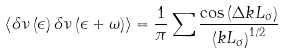Convert formula to latex. <formula><loc_0><loc_0><loc_500><loc_500>\left \langle \delta \nu \left ( \epsilon \right ) \delta \nu \left ( \epsilon + \omega \right ) \right \rangle = \frac { 1 } { \pi } \sum \frac { \cos \left ( \Delta k L _ { \sigma } \right ) } { \left ( k L _ { \sigma } \right ) ^ { 1 / 2 } }</formula> 